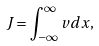Convert formula to latex. <formula><loc_0><loc_0><loc_500><loc_500>J = \int ^ { \infty } _ { - \infty } v d x ,</formula> 